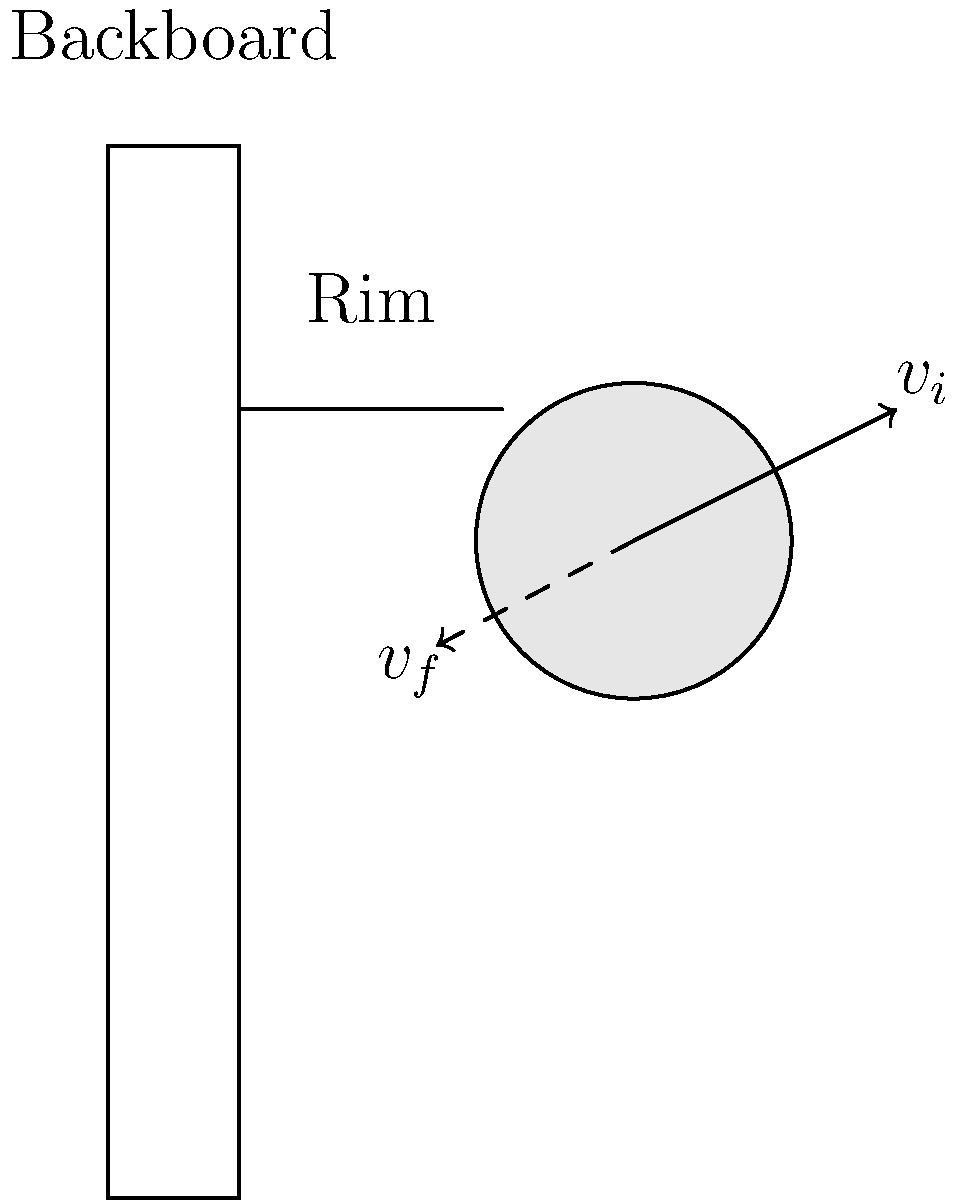As the head coach, you're analyzing the energy transfer during a basketball shot. A basketball with a mass of 0.62 kg approaches the backboard at a velocity of 8 m/s. After colliding with the backboard and rim, it rebounds at 6 m/s. Assuming the collision is elastic, what percentage of the ball's initial kinetic energy is transferred to the backboard and rim system? To solve this problem, we'll follow these steps:

1) Calculate the initial kinetic energy of the basketball:
   $$KE_i = \frac{1}{2}mv_i^2$$
   $$KE_i = \frac{1}{2}(0.62)(8^2) = 19.84 \text{ J}$$

2) Calculate the final kinetic energy of the basketball:
   $$KE_f = \frac{1}{2}mv_f^2$$
   $$KE_f = \frac{1}{2}(0.62)(6^2) = 11.16 \text{ J}$$

3) Calculate the energy transferred to the backboard and rim:
   $$E_{\text{transferred}} = KE_i - KE_f = 19.84 - 11.16 = 8.68 \text{ J}$$

4) Calculate the percentage of initial energy transferred:
   $$\text{Percentage} = \frac{E_{\text{transferred}}}{KE_i} \times 100\%$$
   $$\text{Percentage} = \frac{8.68}{19.84} \times 100\% = 43.75\%$$

Therefore, 43.75% of the ball's initial kinetic energy is transferred to the backboard and rim system.
Answer: 43.75% 